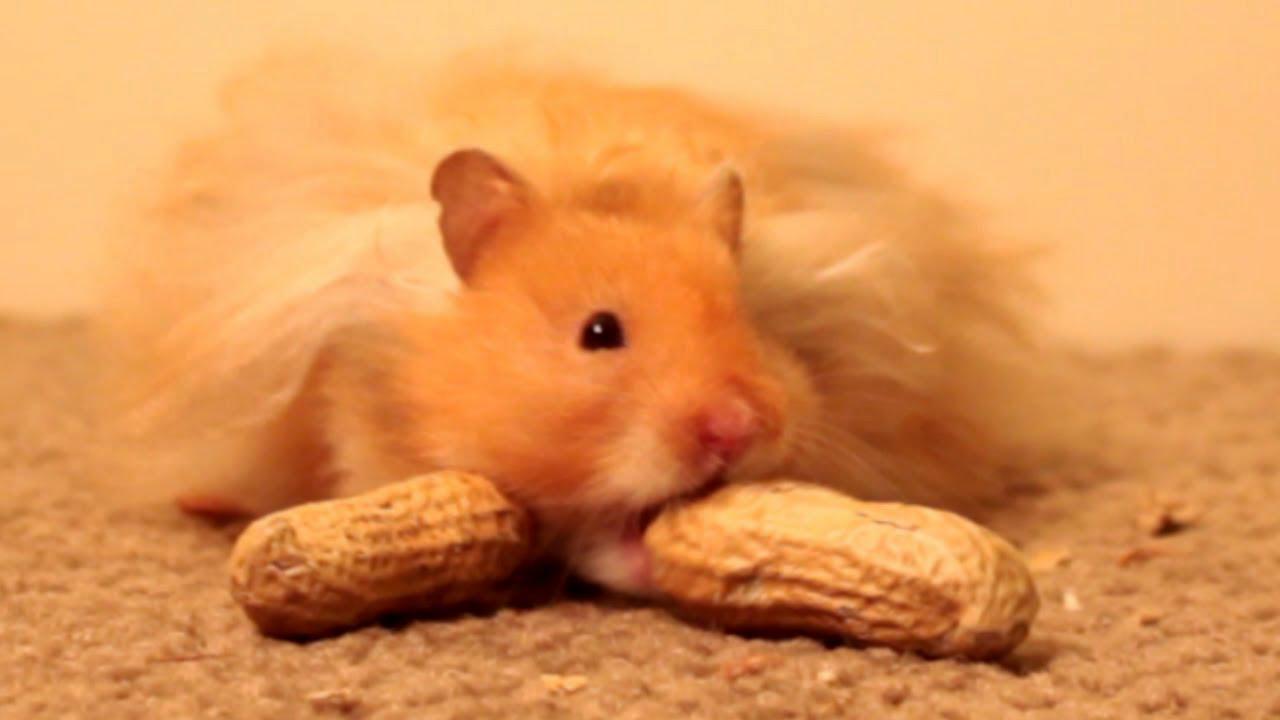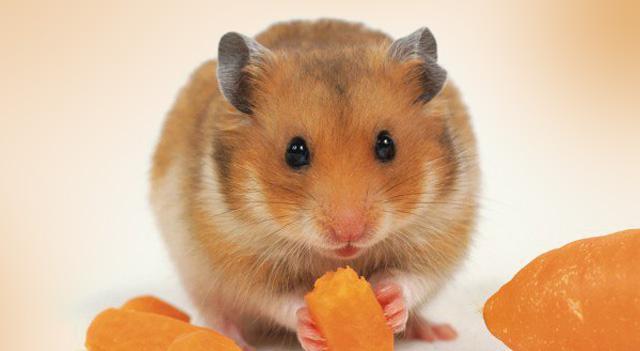The first image is the image on the left, the second image is the image on the right. For the images shown, is this caption "An image shows a pet rodent holding an orange food item in both front paws." true? Answer yes or no. Yes. The first image is the image on the left, the second image is the image on the right. Examine the images to the left and right. Is the description "The rodent is sitting in its food in one of the images." accurate? Answer yes or no. No. 